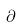<formula> <loc_0><loc_0><loc_500><loc_500>\partial</formula> 